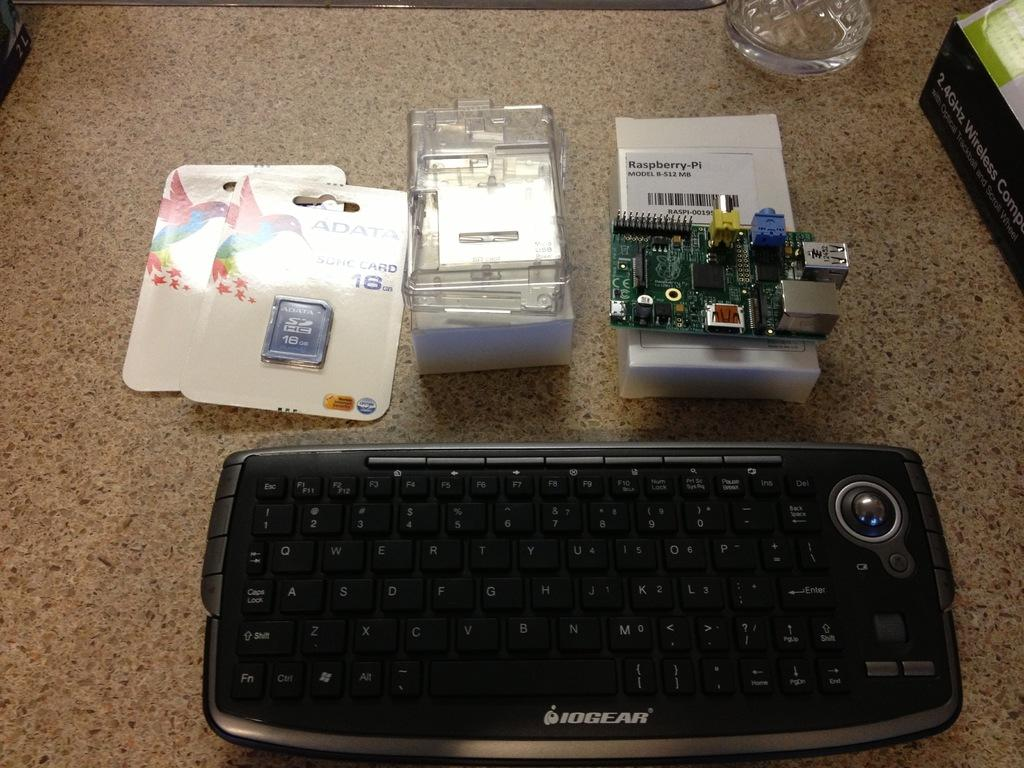Provide a one-sentence caption for the provided image. A IOGEAR black computer keyboard and other hardware parts on a counter. 